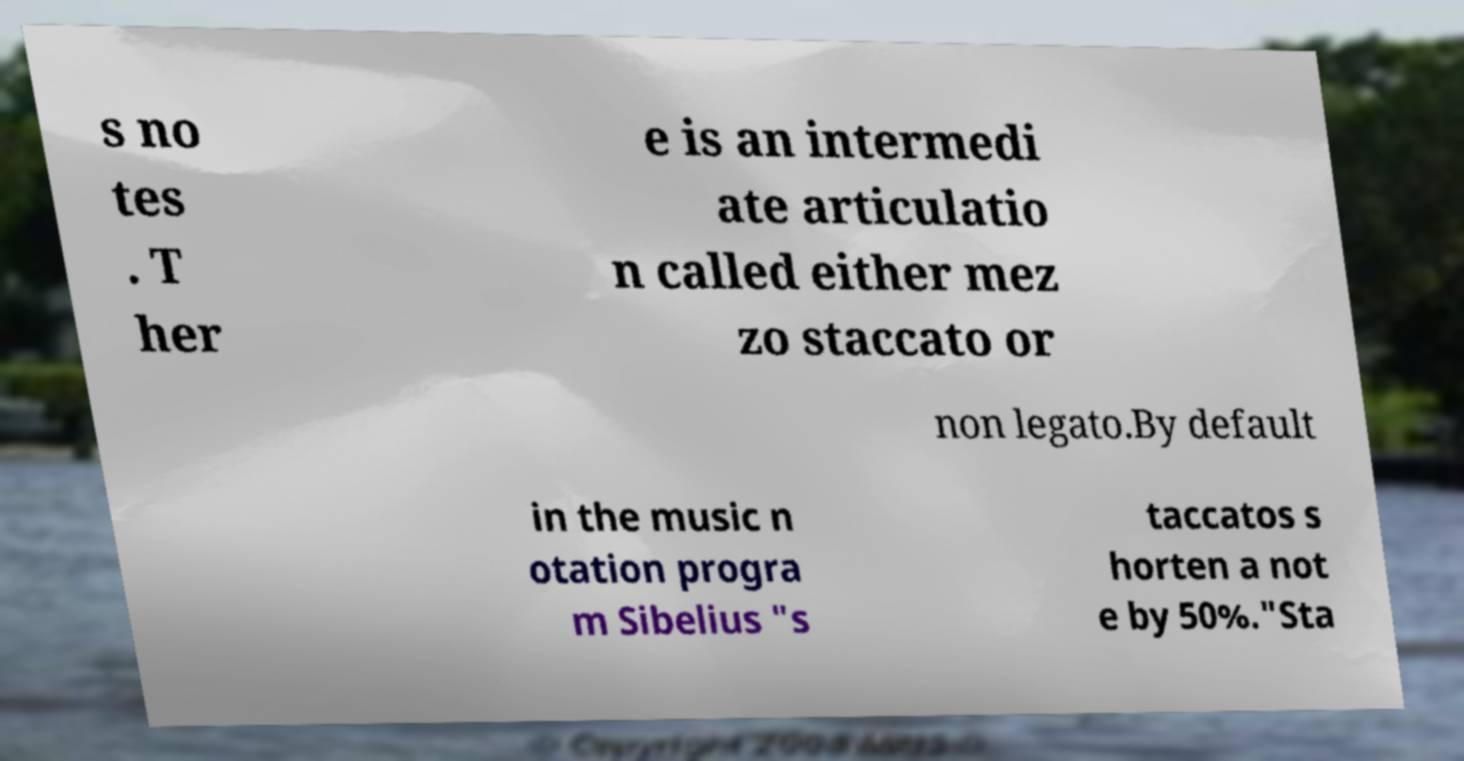Can you read and provide the text displayed in the image?This photo seems to have some interesting text. Can you extract and type it out for me? s no tes . T her e is an intermedi ate articulatio n called either mez zo staccato or non legato.By default in the music n otation progra m Sibelius "s taccatos s horten a not e by 50%."Sta 